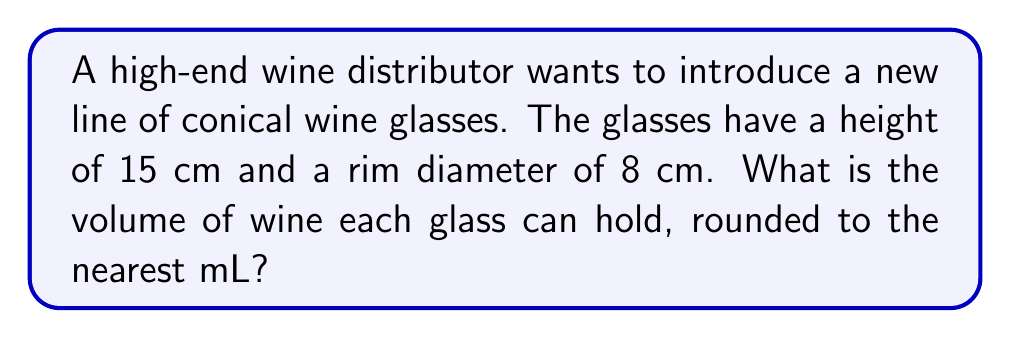What is the answer to this math problem? To find the volume of a conical wine glass, we'll use the formula for the volume of a cone:

$$V = \frac{1}{3}\pi r^2 h$$

Where:
$V$ = volume
$r$ = radius of the base
$h$ = height of the cone

Given:
- Height (h) = 15 cm
- Rim diameter = 8 cm

Step 1: Calculate the radius
The radius is half the diameter:
$r = 8 \div 2 = 4$ cm

Step 2: Apply the volume formula
$$V = \frac{1}{3}\pi (4\text{ cm})^2 (15\text{ cm})$$

Step 3: Calculate
$$V = \frac{1}{3}\pi (16\text{ cm}^2) (15\text{ cm})$$
$$V = 80\pi\text{ cm}^3$$

Step 4: Evaluate and convert to mL
$$V \approx 251.33\text{ cm}^3 = 251.33\text{ mL}$$

Step 5: Round to the nearest mL
$$V \approx 251\text{ mL}$$
Answer: 251 mL 